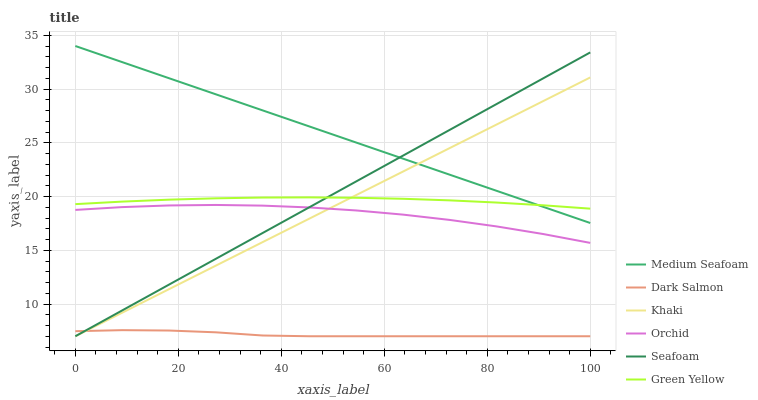Does Seafoam have the minimum area under the curve?
Answer yes or no. No. Does Seafoam have the maximum area under the curve?
Answer yes or no. No. Is Seafoam the smoothest?
Answer yes or no. No. Is Seafoam the roughest?
Answer yes or no. No. Does Green Yellow have the lowest value?
Answer yes or no. No. Does Seafoam have the highest value?
Answer yes or no. No. Is Dark Salmon less than Orchid?
Answer yes or no. Yes. Is Medium Seafoam greater than Dark Salmon?
Answer yes or no. Yes. Does Dark Salmon intersect Orchid?
Answer yes or no. No. 